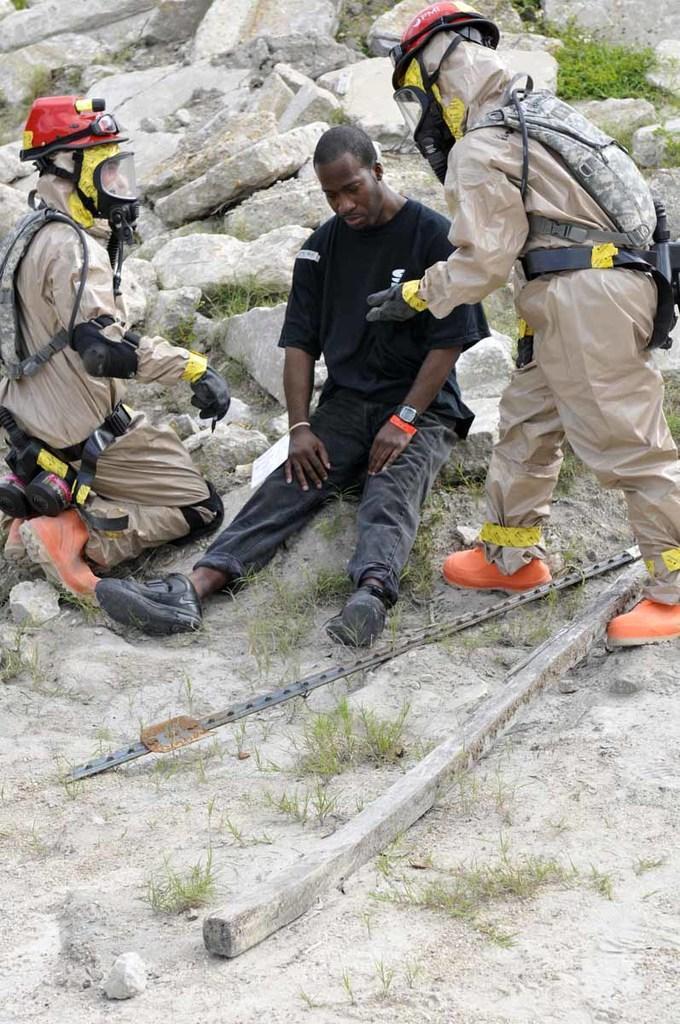Could you give a brief overview of what you see in this image? In this image in the center there is one person who is sitting, and on the right side and left side there are two persons one person is standing and one person is sitting on his knees. At the bottom there is sand, and in the background there are some rocks and grass, and in the foreground there is a wooden stick. 